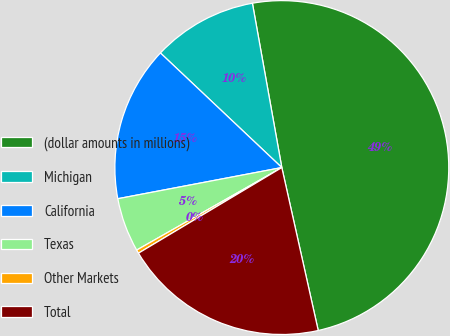Convert chart. <chart><loc_0><loc_0><loc_500><loc_500><pie_chart><fcel>(dollar amounts in millions)<fcel>Michigan<fcel>California<fcel>Texas<fcel>Other Markets<fcel>Total<nl><fcel>49.32%<fcel>10.14%<fcel>15.03%<fcel>5.24%<fcel>0.34%<fcel>19.93%<nl></chart> 